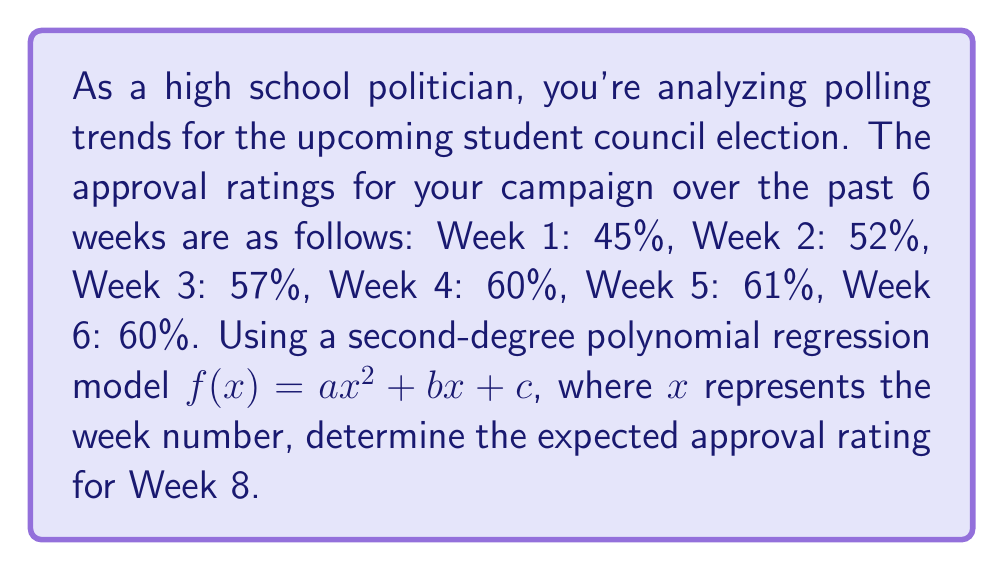Solve this math problem. To solve this problem, we'll use polynomial regression to fit a quadratic function to the data points:

1. Set up the system of equations:
   $$\begin{cases}
   a(1^2) + b(1) + c = 45 \\
   a(2^2) + b(2) + c = 52 \\
   a(3^2) + b(3) + c = 57 \\
   a(4^2) + b(4) + c = 60 \\
   a(5^2) + b(5) + c = 61 \\
   a(6^2) + b(6) + c = 60
   \end{cases}$$

2. Use a polynomial regression calculator or software to find the coefficients:
   $a \approx -0.7143$, $b \approx 9.4286$, $c \approx 36.2857$

3. The resulting quadratic function is:
   $f(x) \approx -0.7143x^2 + 9.4286x + 36.2857$

4. To find the expected approval rating for Week 8, substitute $x = 8$ into the function:
   $$f(8) \approx -0.7143(8^2) + 9.4286(8) + 36.2857$$
   $$f(8) \approx -0.7143(64) + 9.4286(8) + 36.2857$$
   $$f(8) \approx -45.7152 + 75.4288 + 36.2857$$
   $$f(8) \approx 65.9993$$

5. Round to the nearest whole percentage:
   $f(8) \approx 66\%$
Answer: 66% 